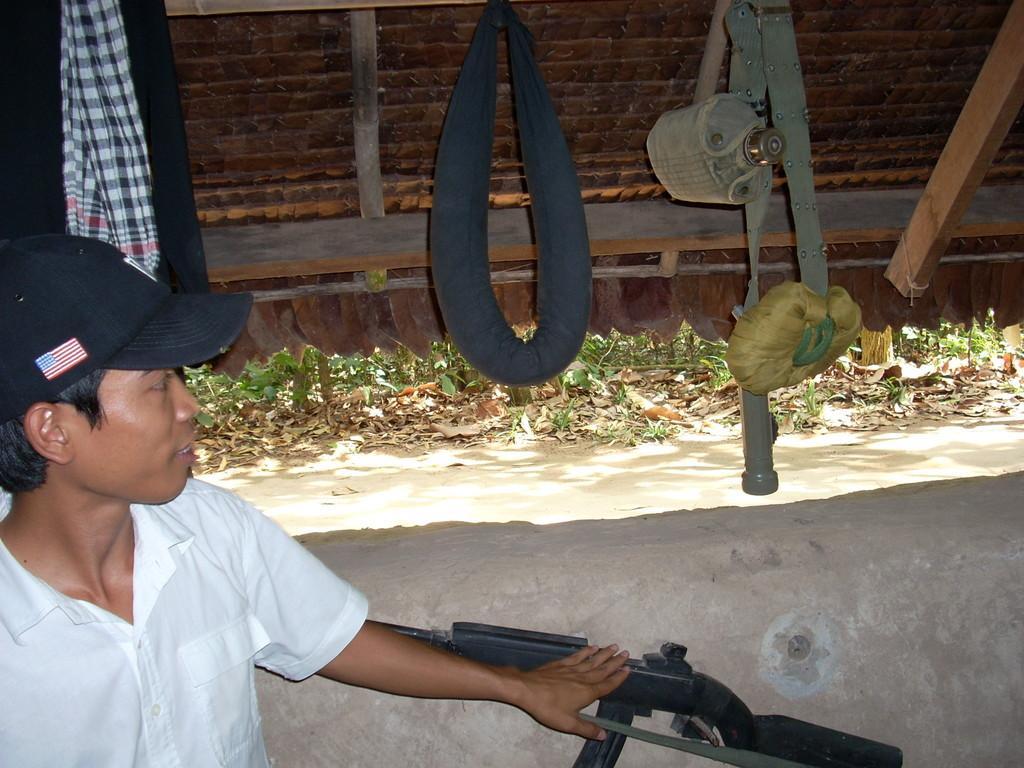Could you give a brief overview of what you see in this image? In this picture there is a boy on the left side of the image and there is a gun at the bottom side of the image, there are clothes in the top left side of the image. 